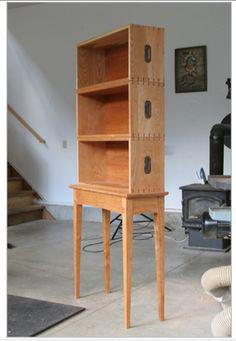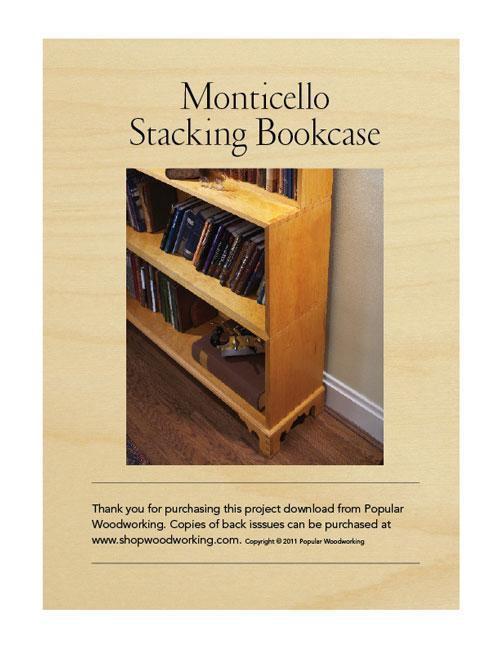The first image is the image on the left, the second image is the image on the right. Analyze the images presented: Is the assertion "One of the images includes a bookcase with glass on the front." valid? Answer yes or no. No. The first image is the image on the left, the second image is the image on the right. Assess this claim about the two images: "The cabinet in the left image has glass panes.". Correct or not? Answer yes or no. No. 